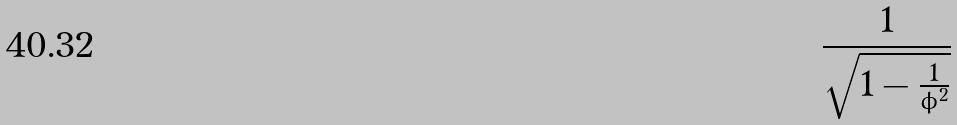Convert formula to latex. <formula><loc_0><loc_0><loc_500><loc_500>\frac { 1 } { \sqrt { 1 - \frac { 1 } { \phi ^ { 2 } } } }</formula> 